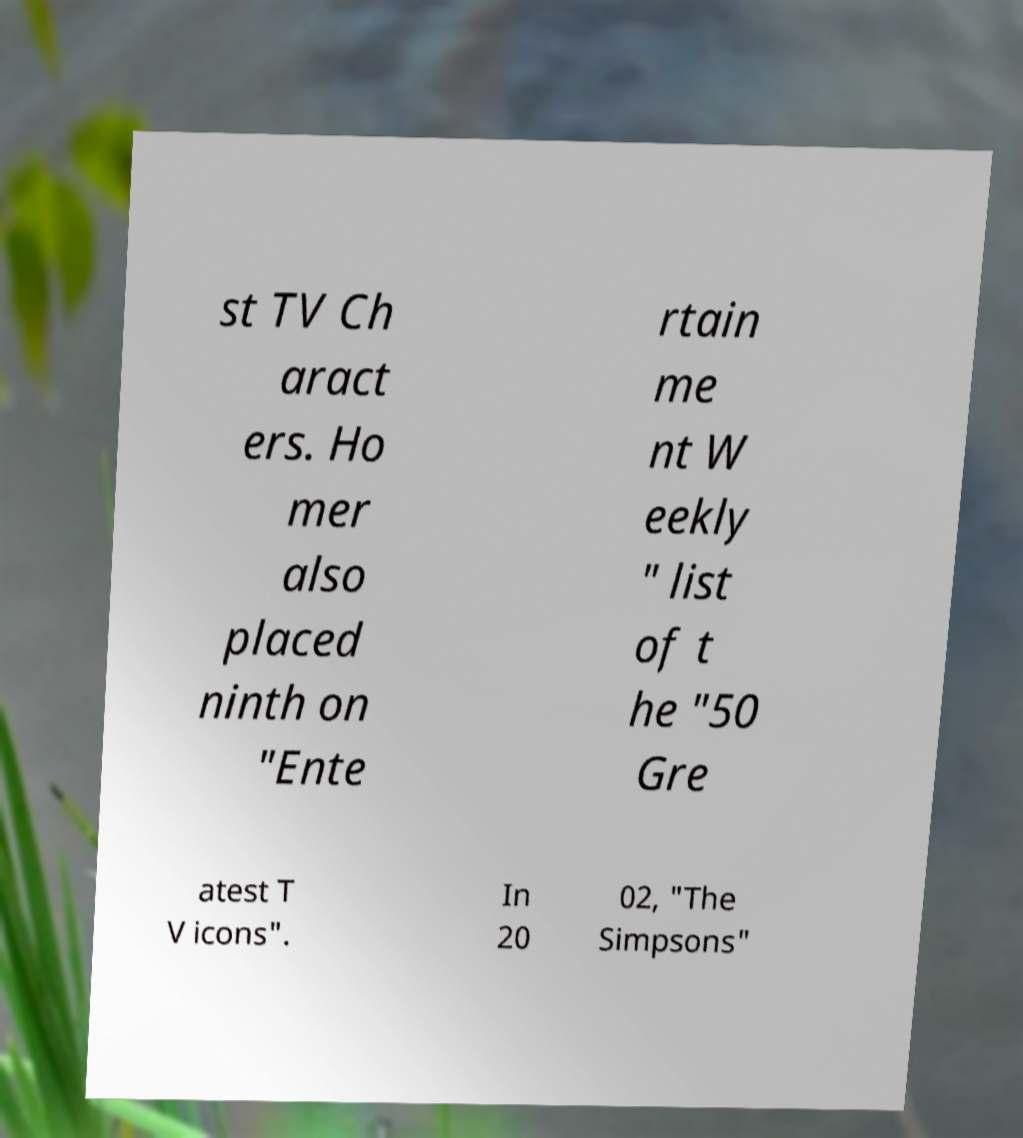Could you assist in decoding the text presented in this image and type it out clearly? st TV Ch aract ers. Ho mer also placed ninth on "Ente rtain me nt W eekly " list of t he "50 Gre atest T V icons". In 20 02, "The Simpsons" 